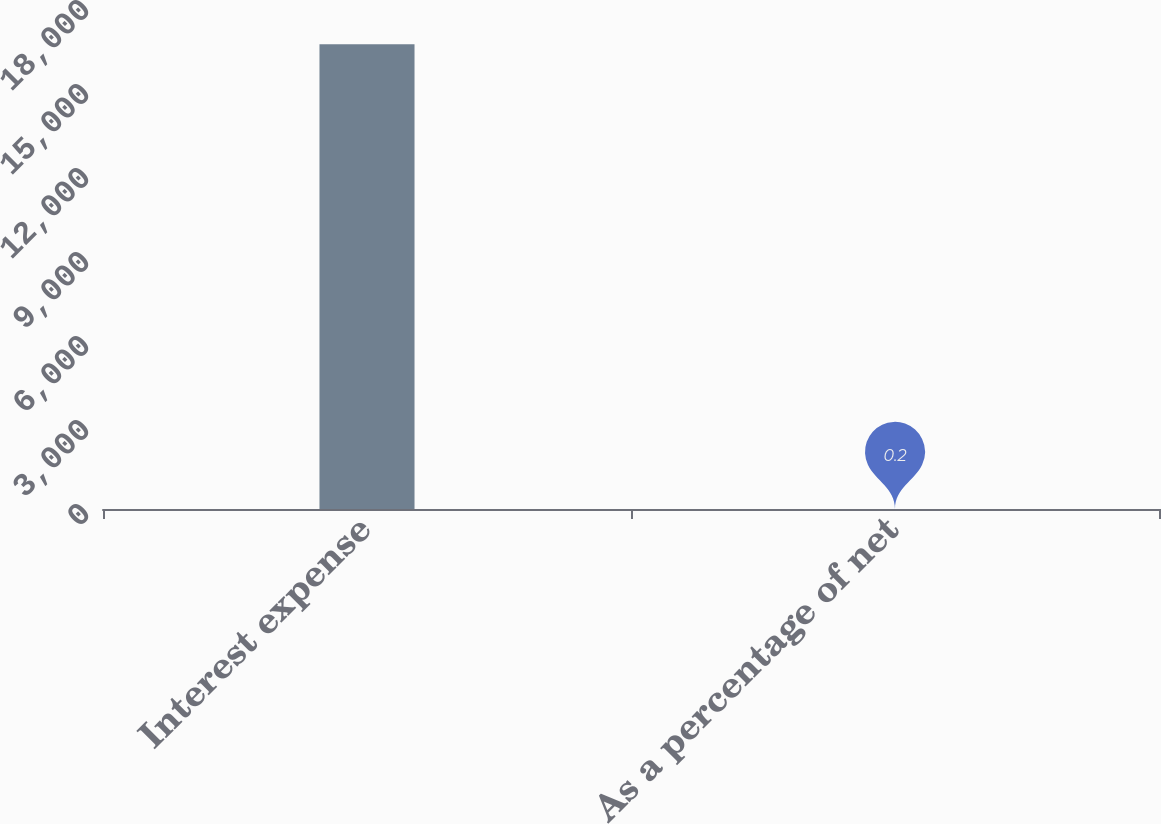Convert chart. <chart><loc_0><loc_0><loc_500><loc_500><bar_chart><fcel>Interest expense<fcel>As a percentage of net<nl><fcel>16600<fcel>0.2<nl></chart> 